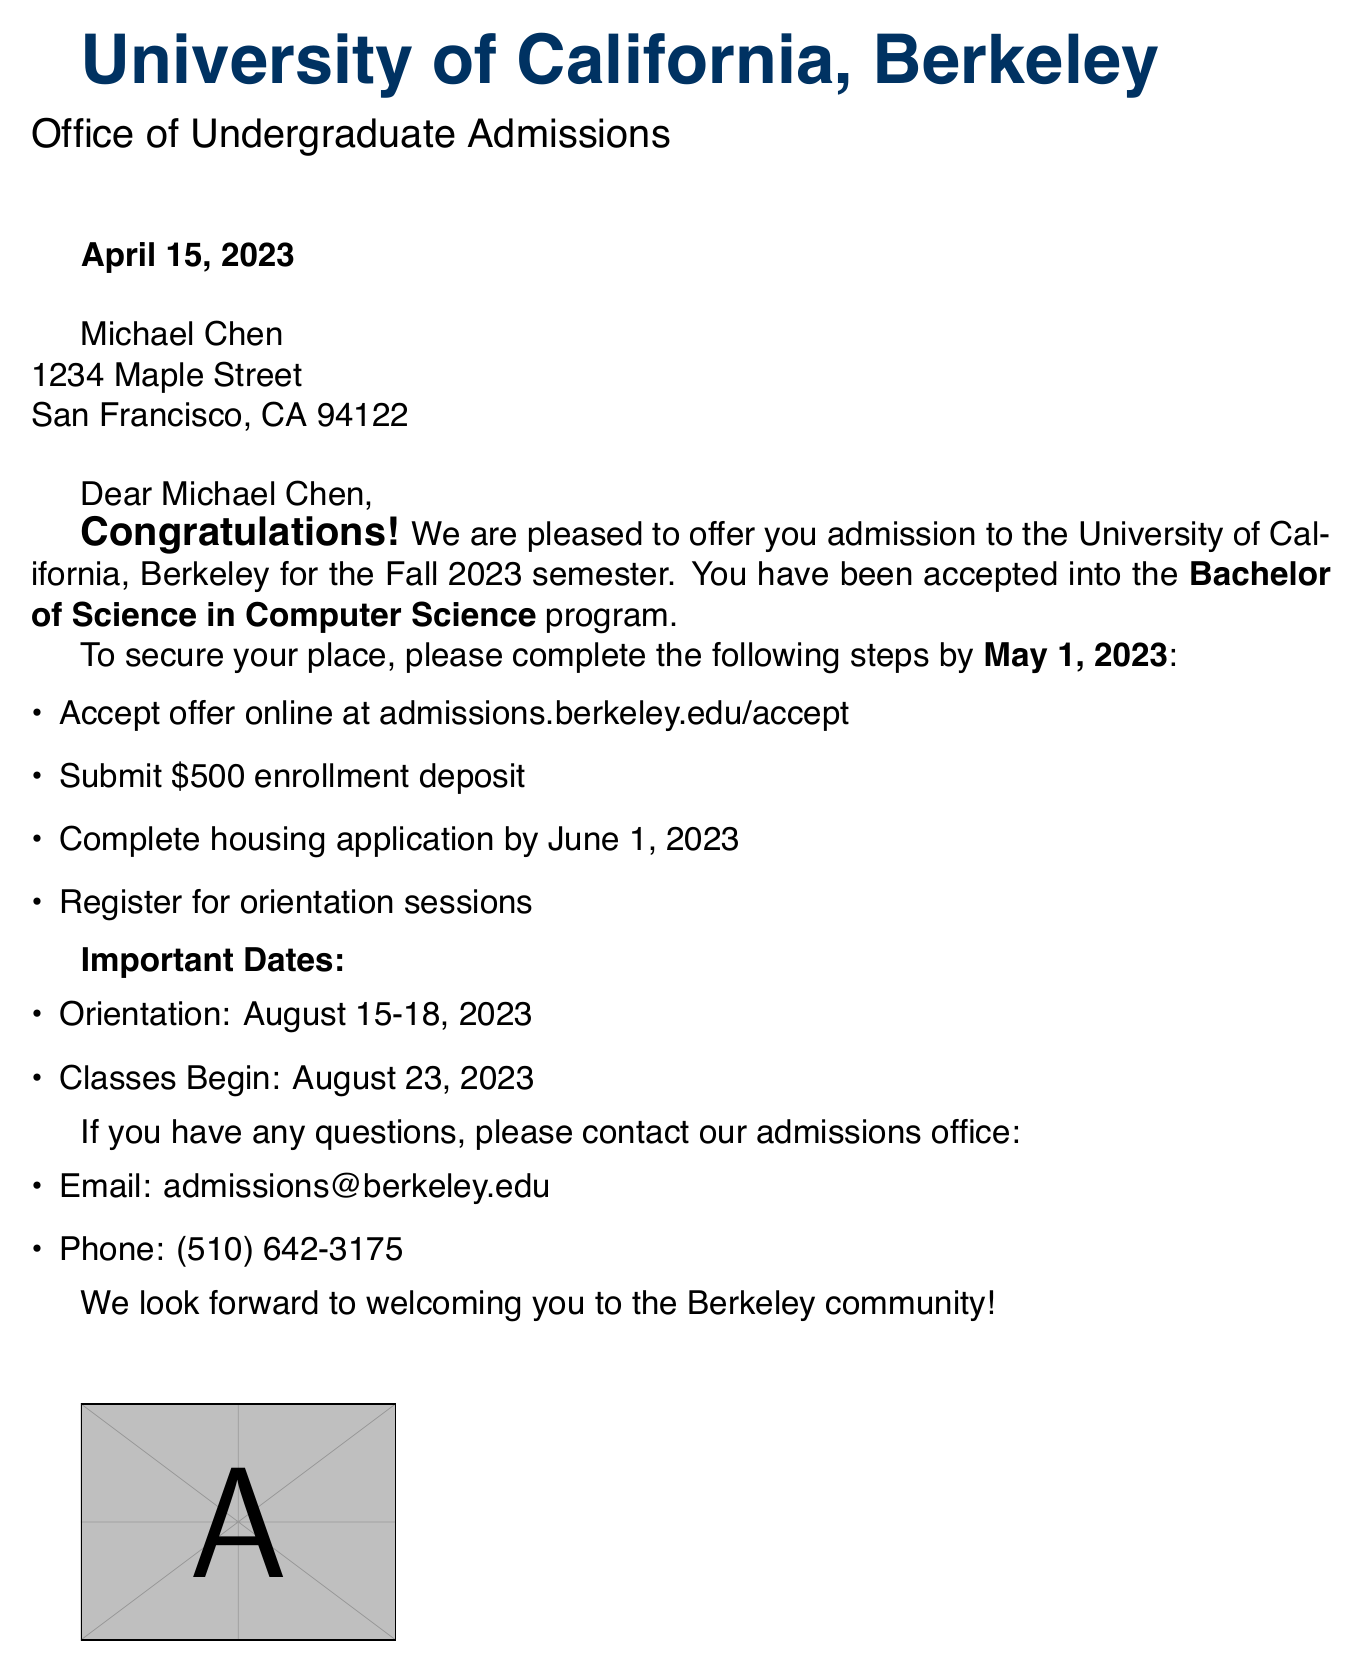What program was Michael Chen accepted into? The document states that he was accepted into the Bachelor of Science in Computer Science program.
Answer: Bachelor of Science in Computer Science What is the enrollment deposit amount? The document specifies that the enrollment deposit is \$500.
Answer: \$500 By what date must Michael accept the offer? The document indicates that the acceptance offer must be completed by May 1, 2023.
Answer: May 1, 2023 When do classes begin? The document notes that classes begin on August 23, 2023.
Answer: August 23, 2023 What is the contact email for the admissions office? The document lists the contact email for the admissions office as admissions@berkeley.edu.
Answer: admissions@berkeley.edu When is the orientation scheduled? According to the document, orientation is scheduled for August 15-18, 2023.
Answer: August 15-18, 2023 What is the deadline for the housing application? The document states that the housing application should be completed by June 1, 2023.
Answer: June 1, 2023 Who signed the acceptance letter? The document reveals that the acceptance letter was signed by Emily Johnson.
Answer: Emily Johnson 